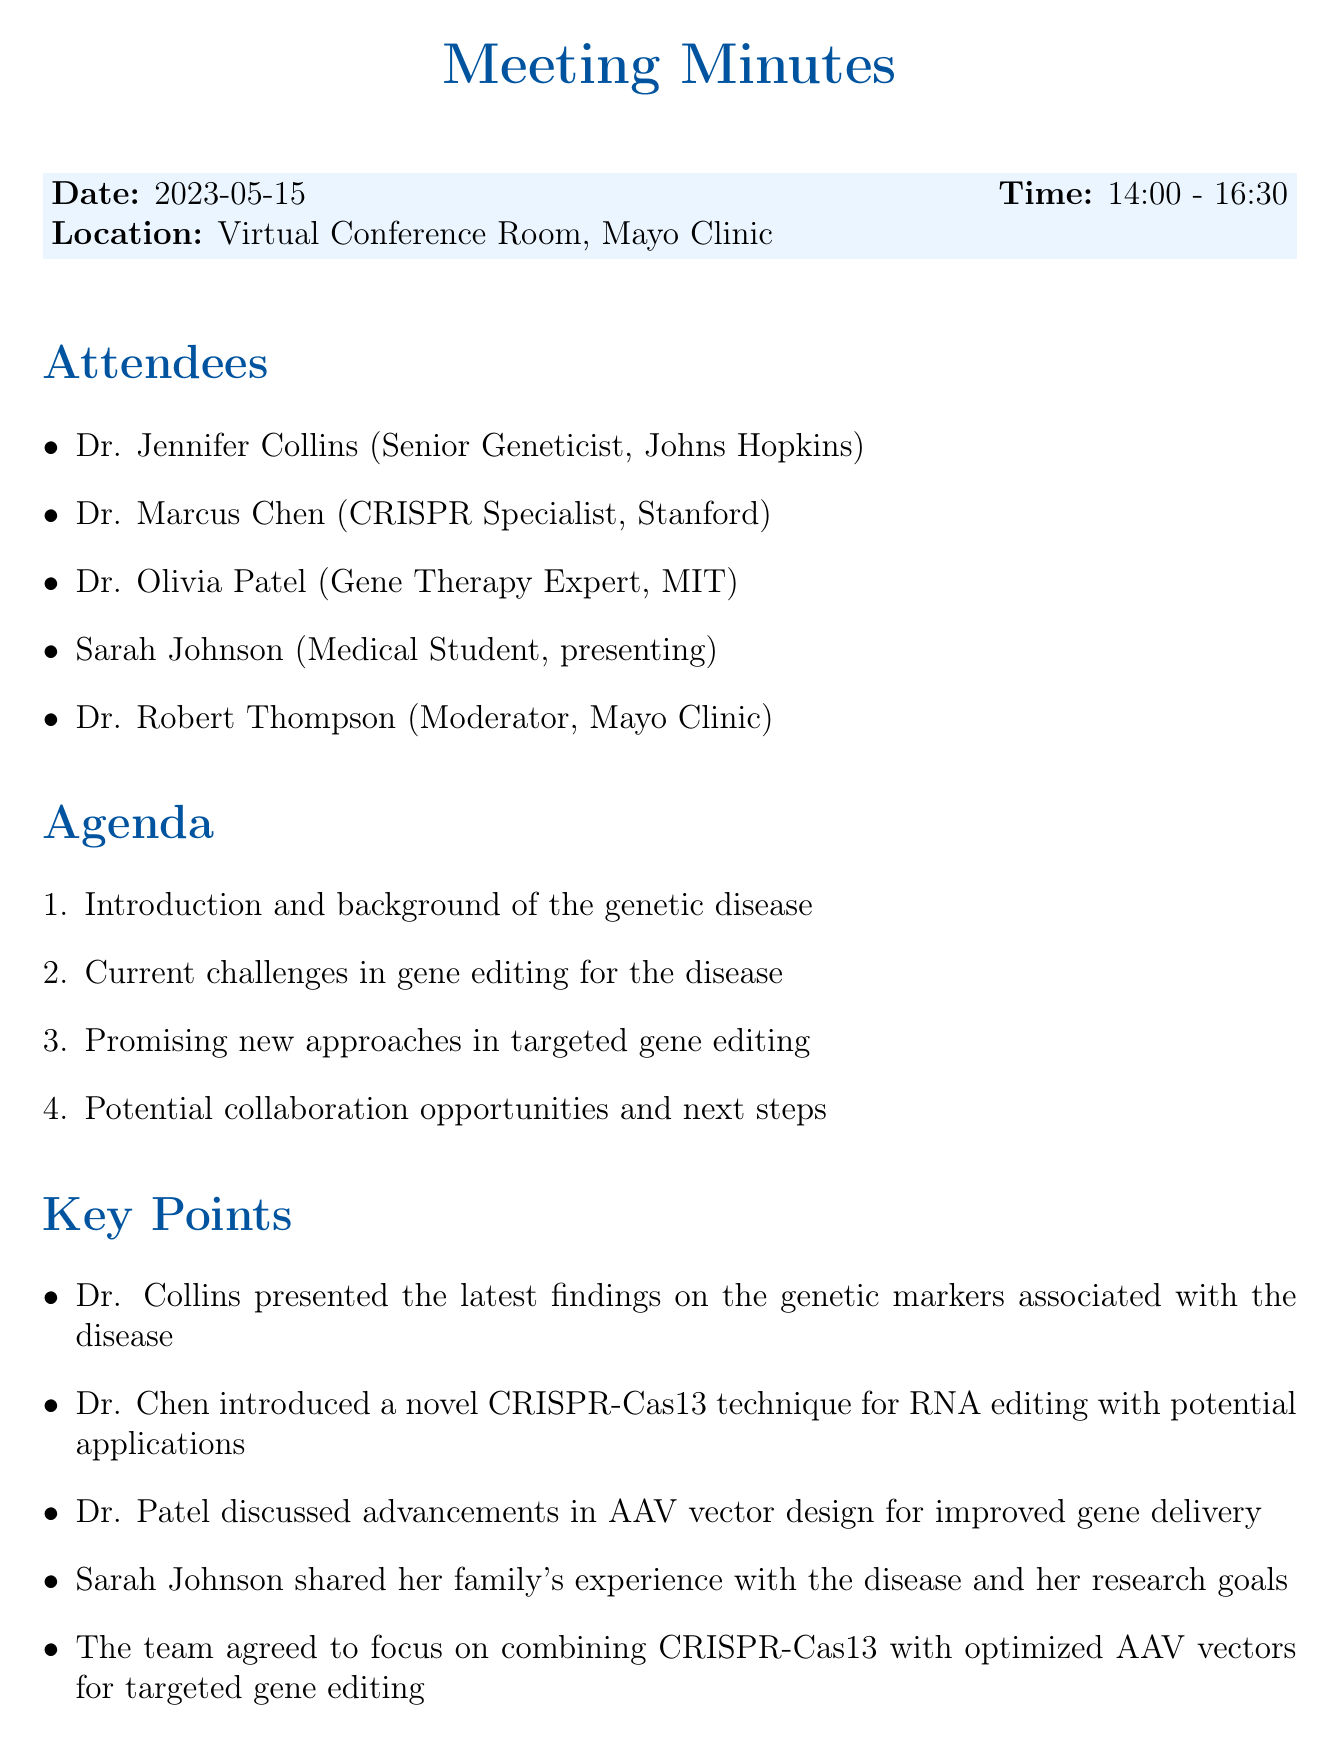what is the date of the meeting? The date of the meeting is stated in the document as "2023-05-15".
Answer: 2023-05-15 who presented the latest findings on the genetic markers associated with the disease? The document mentions that Dr. Jennifer Collins presented the latest findings.
Answer: Dr. Jennifer Collins what is the duration of the meeting? The meeting time is listed as "14:00 - 16:30", indicating a duration of 2 hours and 30 minutes.
Answer: 2 hours and 30 minutes what novel technique did Dr. Chen introduce? The document specifies that Dr. Chen introduced a "novel CRISPR-Cas13 technique for RNA editing".
Answer: CRISPR-Cas13 technique how many attendees were present at the meeting? The document lists a total of five attendees.
Answer: 5 what is the next meeting date? The next meeting date is provided as "2023-06-27".
Answer: 2023-06-27 which expert discussed advancements in AAV vector design? The document notes that Dr. Olivia Patel discussed advancements in AAV vector design.
Answer: Dr. Olivia Patel what action item is assigned to Dr. Thompson? The document states that Dr. Thompson is to "coordinate a follow-up meeting in 6 weeks".
Answer: coordinate a follow-up meeting in 6 weeks what key focus did the team agree on? The document indicates that the team agreed to focus on "combining CRISPR-Cas13 with optimized AAV vectors for targeted gene editing".
Answer: combining CRISPR-Cas13 with optimized AAV vectors for targeted gene editing 